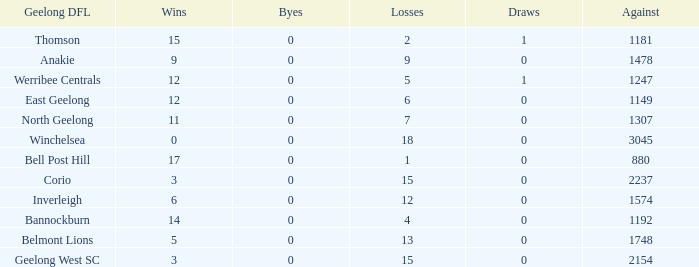What is the total number of losses where the byes were greater than 0? 0.0. 